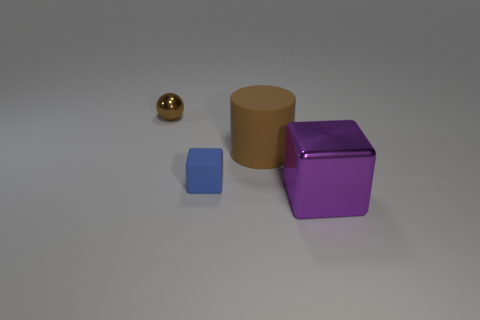How many objects are there, and can you describe their shapes? There are four distinct objects in the image. Starting from the smallest, there is a small blue cube, a golden sphere, a mid-sized cylinder, and a larger purple cube. 